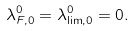Convert formula to latex. <formula><loc_0><loc_0><loc_500><loc_500>\lambda ^ { 0 } _ { F , 0 } = \lambda ^ { 0 } _ { \lim , 0 } = 0 .</formula> 